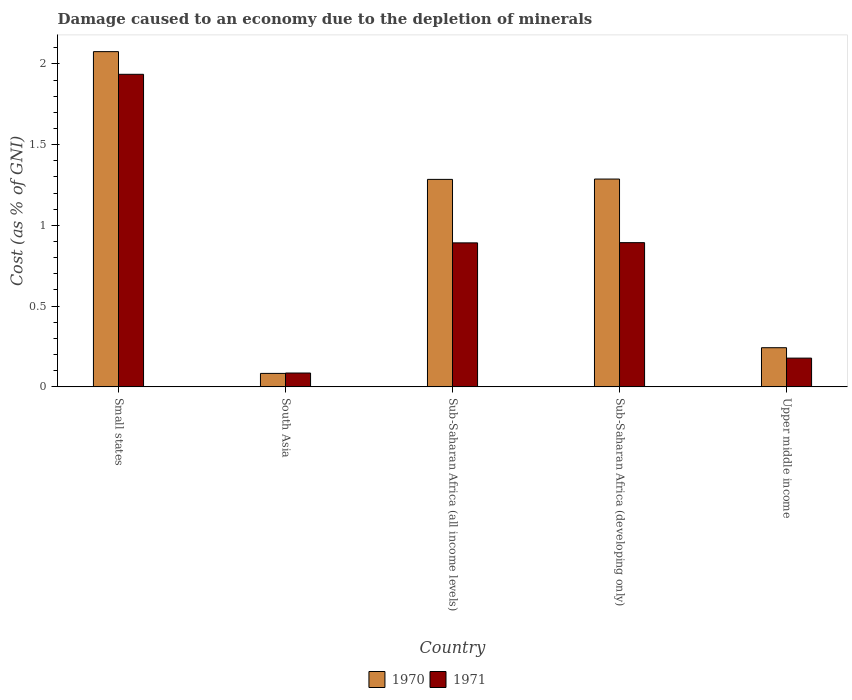Are the number of bars on each tick of the X-axis equal?
Your answer should be very brief. Yes. What is the label of the 5th group of bars from the left?
Keep it short and to the point. Upper middle income. What is the cost of damage caused due to the depletion of minerals in 1971 in Small states?
Your answer should be compact. 1.94. Across all countries, what is the maximum cost of damage caused due to the depletion of minerals in 1971?
Offer a very short reply. 1.94. Across all countries, what is the minimum cost of damage caused due to the depletion of minerals in 1970?
Your response must be concise. 0.08. In which country was the cost of damage caused due to the depletion of minerals in 1970 maximum?
Ensure brevity in your answer.  Small states. What is the total cost of damage caused due to the depletion of minerals in 1971 in the graph?
Give a very brief answer. 3.98. What is the difference between the cost of damage caused due to the depletion of minerals in 1971 in Small states and that in Sub-Saharan Africa (developing only)?
Offer a very short reply. 1.04. What is the difference between the cost of damage caused due to the depletion of minerals in 1970 in Sub-Saharan Africa (all income levels) and the cost of damage caused due to the depletion of minerals in 1971 in Sub-Saharan Africa (developing only)?
Offer a terse response. 0.39. What is the average cost of damage caused due to the depletion of minerals in 1971 per country?
Your answer should be compact. 0.8. What is the difference between the cost of damage caused due to the depletion of minerals of/in 1971 and cost of damage caused due to the depletion of minerals of/in 1970 in Sub-Saharan Africa (all income levels)?
Your response must be concise. -0.39. In how many countries, is the cost of damage caused due to the depletion of minerals in 1971 greater than 1.7 %?
Offer a terse response. 1. What is the ratio of the cost of damage caused due to the depletion of minerals in 1970 in Sub-Saharan Africa (developing only) to that in Upper middle income?
Your response must be concise. 5.31. Is the cost of damage caused due to the depletion of minerals in 1970 in Small states less than that in Sub-Saharan Africa (all income levels)?
Offer a very short reply. No. Is the difference between the cost of damage caused due to the depletion of minerals in 1971 in Small states and Sub-Saharan Africa (all income levels) greater than the difference between the cost of damage caused due to the depletion of minerals in 1970 in Small states and Sub-Saharan Africa (all income levels)?
Your response must be concise. Yes. What is the difference between the highest and the second highest cost of damage caused due to the depletion of minerals in 1971?
Offer a very short reply. -1.04. What is the difference between the highest and the lowest cost of damage caused due to the depletion of minerals in 1970?
Offer a terse response. 1.99. In how many countries, is the cost of damage caused due to the depletion of minerals in 1970 greater than the average cost of damage caused due to the depletion of minerals in 1970 taken over all countries?
Make the answer very short. 3. Is the sum of the cost of damage caused due to the depletion of minerals in 1970 in South Asia and Upper middle income greater than the maximum cost of damage caused due to the depletion of minerals in 1971 across all countries?
Make the answer very short. No. What does the 2nd bar from the right in Sub-Saharan Africa (developing only) represents?
Your answer should be compact. 1970. How many bars are there?
Keep it short and to the point. 10. Are all the bars in the graph horizontal?
Your response must be concise. No. What is the difference between two consecutive major ticks on the Y-axis?
Make the answer very short. 0.5. Does the graph contain any zero values?
Your answer should be compact. No. How are the legend labels stacked?
Your answer should be very brief. Horizontal. What is the title of the graph?
Offer a very short reply. Damage caused to an economy due to the depletion of minerals. Does "1965" appear as one of the legend labels in the graph?
Offer a terse response. No. What is the label or title of the X-axis?
Provide a succinct answer. Country. What is the label or title of the Y-axis?
Provide a short and direct response. Cost (as % of GNI). What is the Cost (as % of GNI) of 1970 in Small states?
Offer a terse response. 2.08. What is the Cost (as % of GNI) of 1971 in Small states?
Keep it short and to the point. 1.94. What is the Cost (as % of GNI) in 1970 in South Asia?
Offer a very short reply. 0.08. What is the Cost (as % of GNI) of 1971 in South Asia?
Your answer should be very brief. 0.09. What is the Cost (as % of GNI) in 1970 in Sub-Saharan Africa (all income levels)?
Provide a succinct answer. 1.28. What is the Cost (as % of GNI) of 1971 in Sub-Saharan Africa (all income levels)?
Provide a short and direct response. 0.89. What is the Cost (as % of GNI) in 1970 in Sub-Saharan Africa (developing only)?
Your answer should be very brief. 1.29. What is the Cost (as % of GNI) of 1971 in Sub-Saharan Africa (developing only)?
Your answer should be compact. 0.89. What is the Cost (as % of GNI) of 1970 in Upper middle income?
Offer a very short reply. 0.24. What is the Cost (as % of GNI) in 1971 in Upper middle income?
Provide a succinct answer. 0.18. Across all countries, what is the maximum Cost (as % of GNI) of 1970?
Provide a succinct answer. 2.08. Across all countries, what is the maximum Cost (as % of GNI) in 1971?
Your response must be concise. 1.94. Across all countries, what is the minimum Cost (as % of GNI) in 1970?
Make the answer very short. 0.08. Across all countries, what is the minimum Cost (as % of GNI) in 1971?
Your answer should be very brief. 0.09. What is the total Cost (as % of GNI) in 1970 in the graph?
Your answer should be compact. 4.97. What is the total Cost (as % of GNI) in 1971 in the graph?
Your answer should be compact. 3.98. What is the difference between the Cost (as % of GNI) of 1970 in Small states and that in South Asia?
Provide a succinct answer. 1.99. What is the difference between the Cost (as % of GNI) of 1971 in Small states and that in South Asia?
Offer a very short reply. 1.85. What is the difference between the Cost (as % of GNI) of 1970 in Small states and that in Sub-Saharan Africa (all income levels)?
Give a very brief answer. 0.79. What is the difference between the Cost (as % of GNI) in 1971 in Small states and that in Sub-Saharan Africa (all income levels)?
Your response must be concise. 1.04. What is the difference between the Cost (as % of GNI) of 1970 in Small states and that in Sub-Saharan Africa (developing only)?
Make the answer very short. 0.79. What is the difference between the Cost (as % of GNI) in 1971 in Small states and that in Sub-Saharan Africa (developing only)?
Provide a short and direct response. 1.04. What is the difference between the Cost (as % of GNI) of 1970 in Small states and that in Upper middle income?
Ensure brevity in your answer.  1.83. What is the difference between the Cost (as % of GNI) of 1971 in Small states and that in Upper middle income?
Offer a very short reply. 1.76. What is the difference between the Cost (as % of GNI) of 1970 in South Asia and that in Sub-Saharan Africa (all income levels)?
Give a very brief answer. -1.2. What is the difference between the Cost (as % of GNI) in 1971 in South Asia and that in Sub-Saharan Africa (all income levels)?
Ensure brevity in your answer.  -0.81. What is the difference between the Cost (as % of GNI) of 1970 in South Asia and that in Sub-Saharan Africa (developing only)?
Keep it short and to the point. -1.2. What is the difference between the Cost (as % of GNI) of 1971 in South Asia and that in Sub-Saharan Africa (developing only)?
Keep it short and to the point. -0.81. What is the difference between the Cost (as % of GNI) in 1970 in South Asia and that in Upper middle income?
Your answer should be very brief. -0.16. What is the difference between the Cost (as % of GNI) of 1971 in South Asia and that in Upper middle income?
Offer a very short reply. -0.09. What is the difference between the Cost (as % of GNI) of 1970 in Sub-Saharan Africa (all income levels) and that in Sub-Saharan Africa (developing only)?
Ensure brevity in your answer.  -0. What is the difference between the Cost (as % of GNI) in 1971 in Sub-Saharan Africa (all income levels) and that in Sub-Saharan Africa (developing only)?
Your response must be concise. -0. What is the difference between the Cost (as % of GNI) of 1970 in Sub-Saharan Africa (all income levels) and that in Upper middle income?
Keep it short and to the point. 1.04. What is the difference between the Cost (as % of GNI) of 1971 in Sub-Saharan Africa (all income levels) and that in Upper middle income?
Ensure brevity in your answer.  0.71. What is the difference between the Cost (as % of GNI) in 1970 in Sub-Saharan Africa (developing only) and that in Upper middle income?
Ensure brevity in your answer.  1.04. What is the difference between the Cost (as % of GNI) of 1971 in Sub-Saharan Africa (developing only) and that in Upper middle income?
Offer a terse response. 0.71. What is the difference between the Cost (as % of GNI) in 1970 in Small states and the Cost (as % of GNI) in 1971 in South Asia?
Give a very brief answer. 1.99. What is the difference between the Cost (as % of GNI) of 1970 in Small states and the Cost (as % of GNI) of 1971 in Sub-Saharan Africa (all income levels)?
Your answer should be compact. 1.18. What is the difference between the Cost (as % of GNI) of 1970 in Small states and the Cost (as % of GNI) of 1971 in Sub-Saharan Africa (developing only)?
Your response must be concise. 1.18. What is the difference between the Cost (as % of GNI) of 1970 in Small states and the Cost (as % of GNI) of 1971 in Upper middle income?
Ensure brevity in your answer.  1.9. What is the difference between the Cost (as % of GNI) of 1970 in South Asia and the Cost (as % of GNI) of 1971 in Sub-Saharan Africa (all income levels)?
Ensure brevity in your answer.  -0.81. What is the difference between the Cost (as % of GNI) of 1970 in South Asia and the Cost (as % of GNI) of 1971 in Sub-Saharan Africa (developing only)?
Your answer should be compact. -0.81. What is the difference between the Cost (as % of GNI) of 1970 in South Asia and the Cost (as % of GNI) of 1971 in Upper middle income?
Provide a short and direct response. -0.09. What is the difference between the Cost (as % of GNI) in 1970 in Sub-Saharan Africa (all income levels) and the Cost (as % of GNI) in 1971 in Sub-Saharan Africa (developing only)?
Your answer should be compact. 0.39. What is the difference between the Cost (as % of GNI) of 1970 in Sub-Saharan Africa (all income levels) and the Cost (as % of GNI) of 1971 in Upper middle income?
Your answer should be very brief. 1.11. What is the difference between the Cost (as % of GNI) in 1970 in Sub-Saharan Africa (developing only) and the Cost (as % of GNI) in 1971 in Upper middle income?
Provide a succinct answer. 1.11. What is the average Cost (as % of GNI) of 1971 per country?
Your response must be concise. 0.8. What is the difference between the Cost (as % of GNI) of 1970 and Cost (as % of GNI) of 1971 in Small states?
Your response must be concise. 0.14. What is the difference between the Cost (as % of GNI) in 1970 and Cost (as % of GNI) in 1971 in South Asia?
Ensure brevity in your answer.  -0. What is the difference between the Cost (as % of GNI) of 1970 and Cost (as % of GNI) of 1971 in Sub-Saharan Africa (all income levels)?
Ensure brevity in your answer.  0.39. What is the difference between the Cost (as % of GNI) of 1970 and Cost (as % of GNI) of 1971 in Sub-Saharan Africa (developing only)?
Give a very brief answer. 0.39. What is the difference between the Cost (as % of GNI) of 1970 and Cost (as % of GNI) of 1971 in Upper middle income?
Make the answer very short. 0.06. What is the ratio of the Cost (as % of GNI) of 1970 in Small states to that in South Asia?
Your answer should be compact. 24.88. What is the ratio of the Cost (as % of GNI) of 1971 in Small states to that in South Asia?
Your response must be concise. 22.57. What is the ratio of the Cost (as % of GNI) of 1970 in Small states to that in Sub-Saharan Africa (all income levels)?
Your answer should be very brief. 1.62. What is the ratio of the Cost (as % of GNI) of 1971 in Small states to that in Sub-Saharan Africa (all income levels)?
Offer a very short reply. 2.17. What is the ratio of the Cost (as % of GNI) of 1970 in Small states to that in Sub-Saharan Africa (developing only)?
Offer a terse response. 1.61. What is the ratio of the Cost (as % of GNI) in 1971 in Small states to that in Sub-Saharan Africa (developing only)?
Your answer should be compact. 2.17. What is the ratio of the Cost (as % of GNI) in 1970 in Small states to that in Upper middle income?
Ensure brevity in your answer.  8.56. What is the ratio of the Cost (as % of GNI) in 1971 in Small states to that in Upper middle income?
Offer a very short reply. 10.87. What is the ratio of the Cost (as % of GNI) of 1970 in South Asia to that in Sub-Saharan Africa (all income levels)?
Provide a succinct answer. 0.06. What is the ratio of the Cost (as % of GNI) of 1971 in South Asia to that in Sub-Saharan Africa (all income levels)?
Your answer should be compact. 0.1. What is the ratio of the Cost (as % of GNI) of 1970 in South Asia to that in Sub-Saharan Africa (developing only)?
Make the answer very short. 0.06. What is the ratio of the Cost (as % of GNI) in 1971 in South Asia to that in Sub-Saharan Africa (developing only)?
Ensure brevity in your answer.  0.1. What is the ratio of the Cost (as % of GNI) in 1970 in South Asia to that in Upper middle income?
Ensure brevity in your answer.  0.34. What is the ratio of the Cost (as % of GNI) of 1971 in South Asia to that in Upper middle income?
Give a very brief answer. 0.48. What is the ratio of the Cost (as % of GNI) in 1970 in Sub-Saharan Africa (all income levels) to that in Upper middle income?
Provide a short and direct response. 5.3. What is the ratio of the Cost (as % of GNI) of 1971 in Sub-Saharan Africa (all income levels) to that in Upper middle income?
Ensure brevity in your answer.  5.01. What is the ratio of the Cost (as % of GNI) of 1970 in Sub-Saharan Africa (developing only) to that in Upper middle income?
Provide a short and direct response. 5.31. What is the ratio of the Cost (as % of GNI) of 1971 in Sub-Saharan Africa (developing only) to that in Upper middle income?
Offer a terse response. 5.02. What is the difference between the highest and the second highest Cost (as % of GNI) of 1970?
Keep it short and to the point. 0.79. What is the difference between the highest and the second highest Cost (as % of GNI) of 1971?
Ensure brevity in your answer.  1.04. What is the difference between the highest and the lowest Cost (as % of GNI) in 1970?
Ensure brevity in your answer.  1.99. What is the difference between the highest and the lowest Cost (as % of GNI) of 1971?
Make the answer very short. 1.85. 